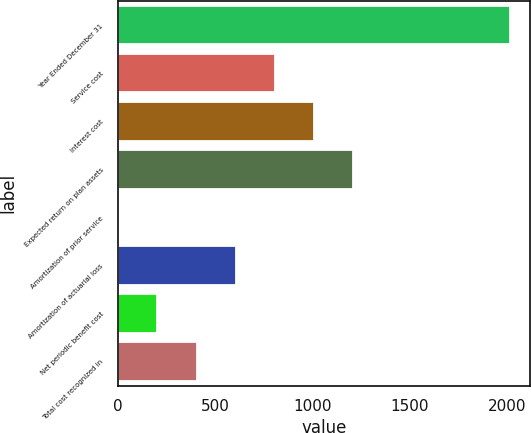Convert chart. <chart><loc_0><loc_0><loc_500><loc_500><bar_chart><fcel>Year Ended December 31<fcel>Service cost<fcel>Interest cost<fcel>Expected return on plan assets<fcel>Amortization of prior service<fcel>Amortization of actuarial loss<fcel>Net periodic benefit cost<fcel>Total cost recognized in<nl><fcel>2014<fcel>806.8<fcel>1008<fcel>1209.2<fcel>2<fcel>605.6<fcel>203.2<fcel>404.4<nl></chart> 